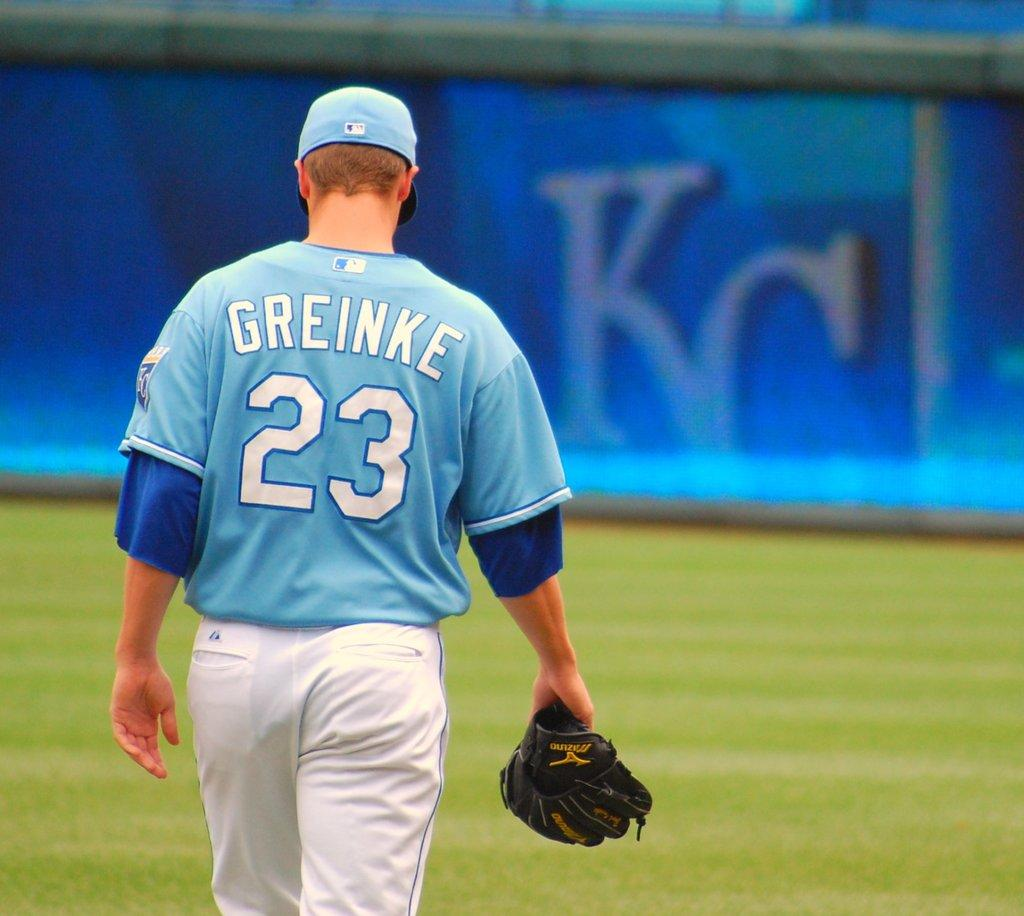Provide a one-sentence caption for the provided image. A basball player called Greinke and wearing the number 23 walks away from the camera carrying his mitt. 